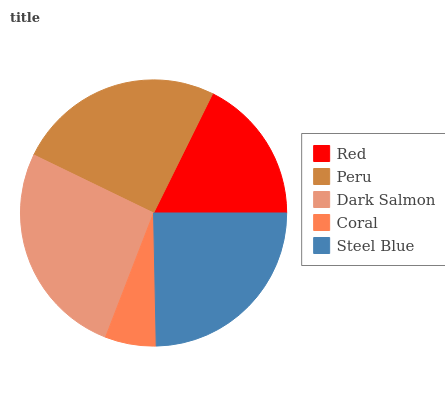Is Coral the minimum?
Answer yes or no. Yes. Is Dark Salmon the maximum?
Answer yes or no. Yes. Is Peru the minimum?
Answer yes or no. No. Is Peru the maximum?
Answer yes or no. No. Is Peru greater than Red?
Answer yes or no. Yes. Is Red less than Peru?
Answer yes or no. Yes. Is Red greater than Peru?
Answer yes or no. No. Is Peru less than Red?
Answer yes or no. No. Is Steel Blue the high median?
Answer yes or no. Yes. Is Steel Blue the low median?
Answer yes or no. Yes. Is Coral the high median?
Answer yes or no. No. Is Coral the low median?
Answer yes or no. No. 